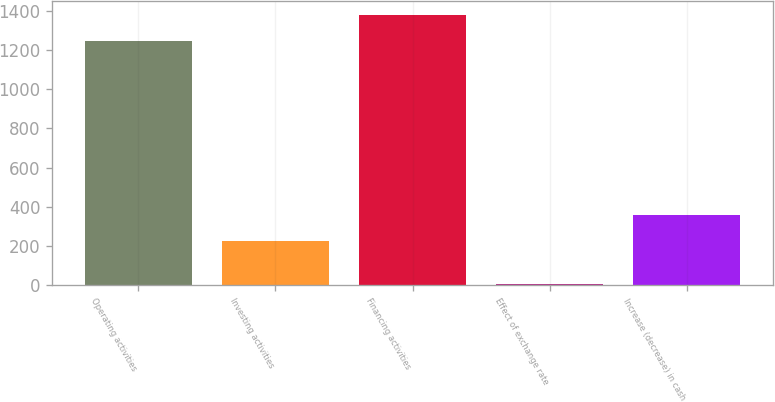Convert chart to OTSL. <chart><loc_0><loc_0><loc_500><loc_500><bar_chart><fcel>Operating activities<fcel>Investing activities<fcel>Financing activities<fcel>Effect of exchange rate<fcel>Increase (decrease) in cash<nl><fcel>1246<fcel>225<fcel>1379.8<fcel>6<fcel>358.8<nl></chart> 